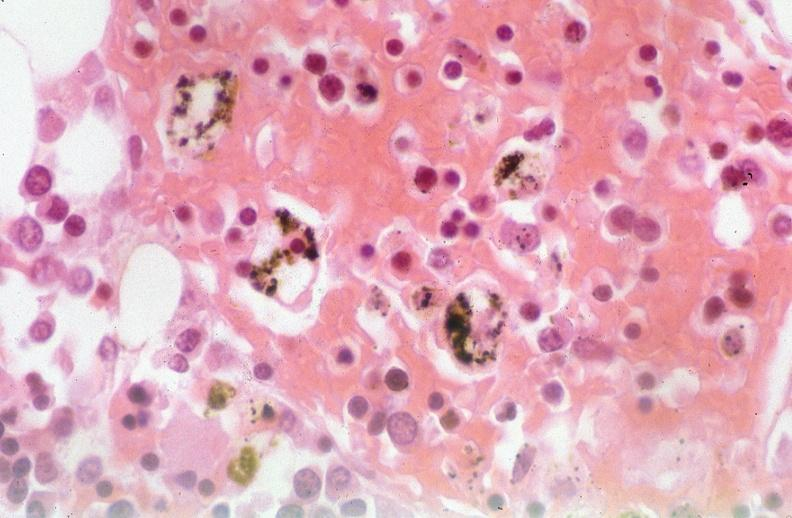does purulent sinusitis show pleura, talc reaction?
Answer the question using a single word or phrase. No 